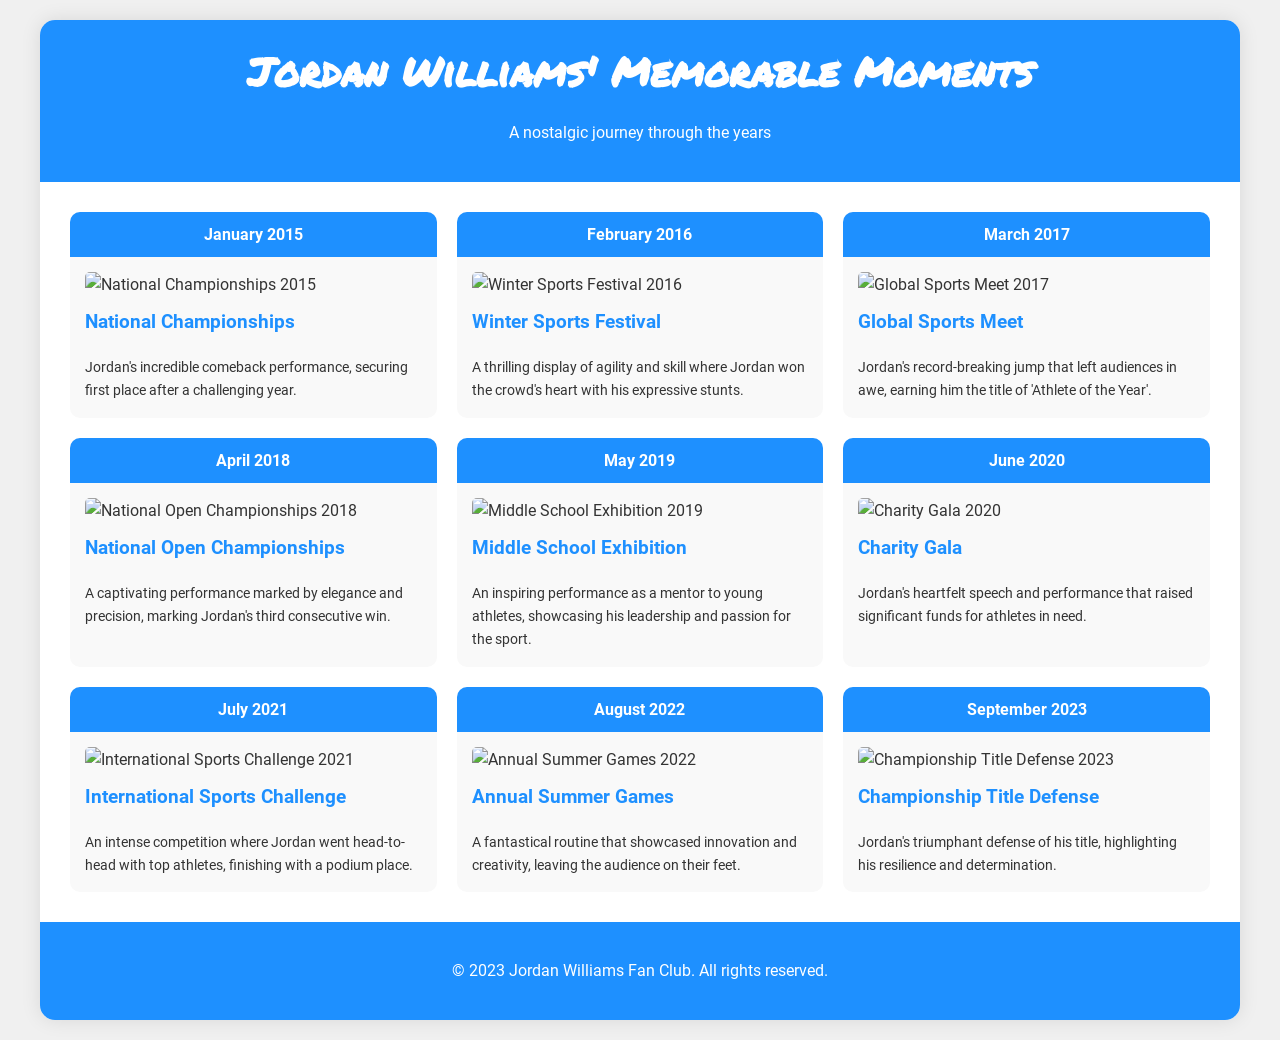What event took place in January 2015? The event listed for January 2015 is the National Championships.
Answer: National Championships How many consecutive wins did Jordan achieve by April 2018? By April 2018, Jordan marked his third consecutive win at the National Open Championships.
Answer: Three What was the date of the Charity Gala? The Charity Gala took place in June 2020.
Answer: June 2020 Which event featured Jordan mentoring young athletes? The Middle School Exhibition in May 2019 showcased Jordan's mentorship.
Answer: Middle School Exhibition What notable title did Jordan earn at the Global Sports Meet? Jordan earned the title of 'Athlete of the Year' at the Global Sports Meet in March 2017.
Answer: Athlete of the Year What is the main theme of the document? The document highlights memorable moments from Jordan Williams' performances over the years.
Answer: Memorable moments What image is associated with the event in September 2023? The image associated with the Championship Title Defense in September 2023 is titled "jordan_championship_defense_2023.jpg".
Answer: jordan_championship_defense_2023.jpg Which performance was highlighted in August 2022? August 2022 highlighted a performance at the Annual Summer Games showcasing innovation and creativity.
Answer: Annual Summer Games What location was the Winter Sports Festival held in February 2016? The document does not specify a location for the Winter Sports Festival.
Answer: Not specified 